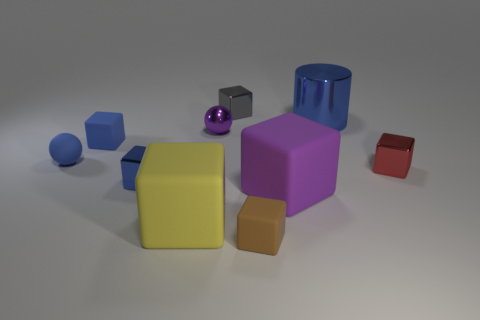How many blue cubes must be subtracted to get 1 blue cubes? 1 Subtract 2 blocks. How many blocks are left? 5 Subtract all blue cubes. How many cubes are left? 5 Subtract all small gray cubes. How many cubes are left? 6 Subtract all blue blocks. Subtract all blue balls. How many blocks are left? 5 Subtract all cylinders. How many objects are left? 9 Subtract 0 brown cylinders. How many objects are left? 10 Subtract all big blue things. Subtract all blue metallic cylinders. How many objects are left? 8 Add 5 tiny gray objects. How many tiny gray objects are left? 6 Add 1 matte cubes. How many matte cubes exist? 5 